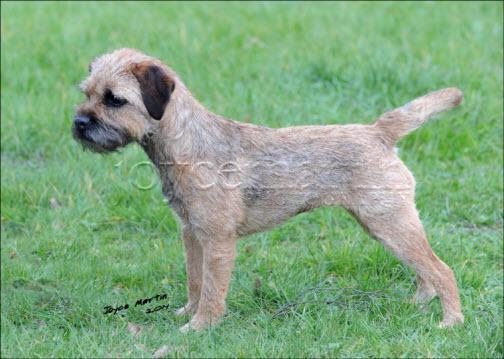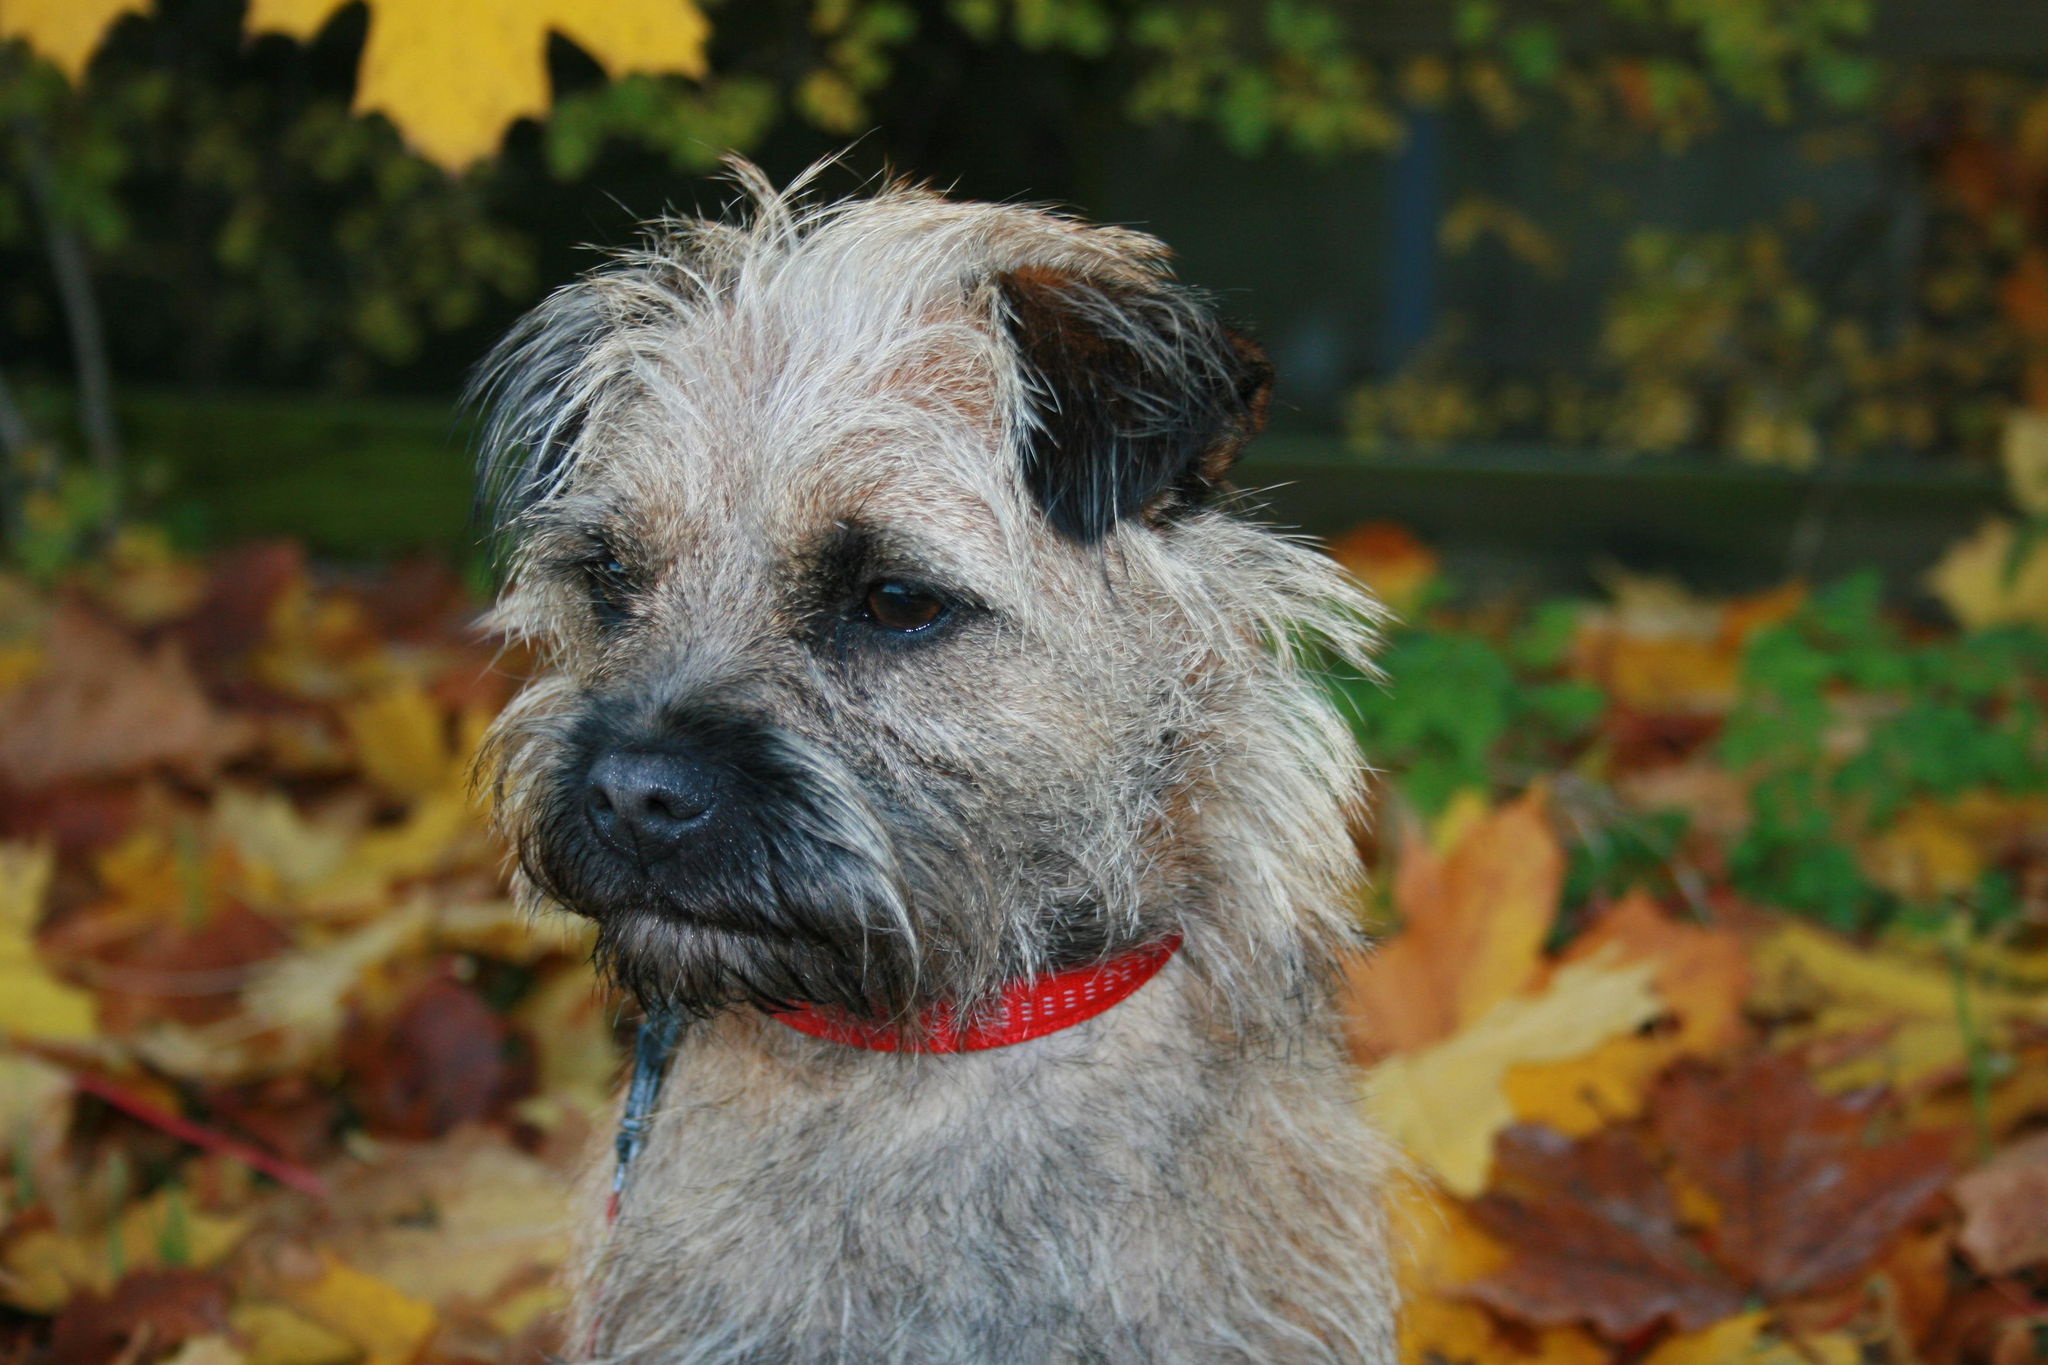The first image is the image on the left, the second image is the image on the right. Examine the images to the left and right. Is the description "The left and right image contains the same number of dogs with at least one in the grass and leaves." accurate? Answer yes or no. Yes. The first image is the image on the left, the second image is the image on the right. For the images shown, is this caption "The is an image of a black and white dog in each picture." true? Answer yes or no. No. 